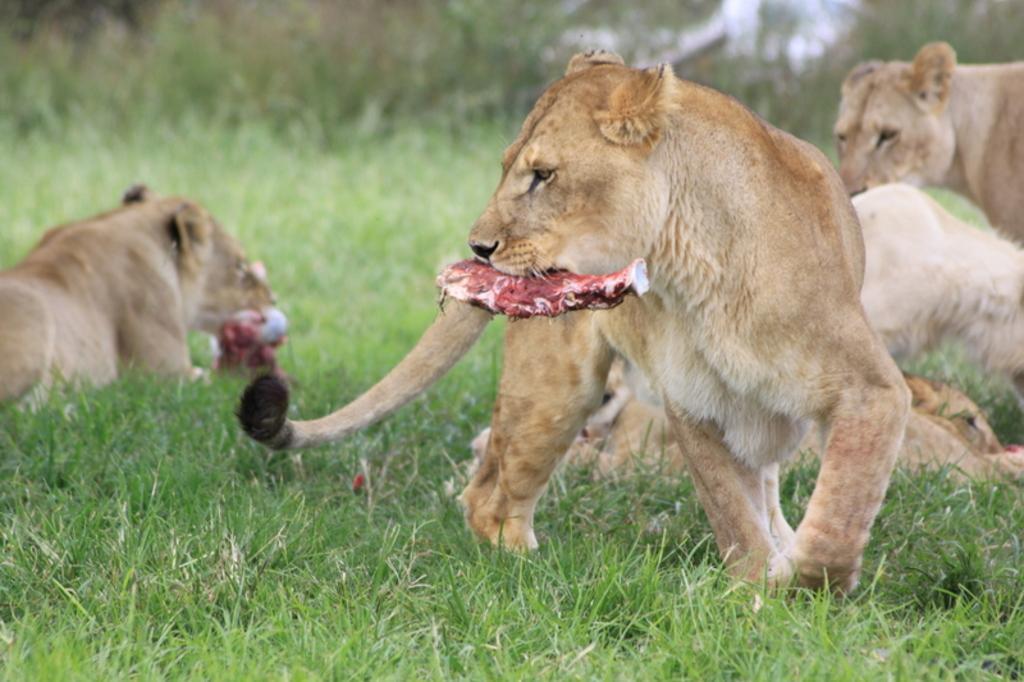Can you describe this image briefly? In this image I can see number of animals. Also I can see ground with grass 